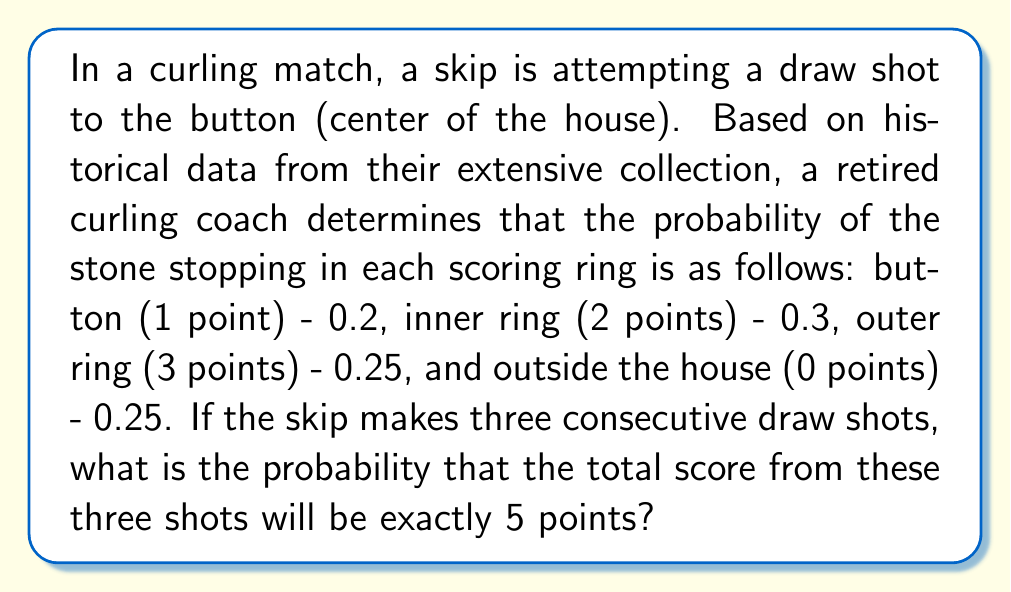Show me your answer to this math problem. Let's approach this step-by-step:

1) First, we need to identify all the possible combinations of shots that result in a total of 5 points. These are:
   - 1 + 1 + 3
   - 1 + 2 + 2
   - 2 + 3 + 0

2) Now, let's calculate the probability of each combination:

   a) P(1 + 1 + 3) = $0.2 \times 0.2 \times 0.25 \times 3! = 0.03$
      (The 3! accounts for all possible orders of these shots)

   b) P(1 + 2 + 2) = $0.2 \times 0.3 \times 0.3 \times 3 = 0.054$
      (The 3 accounts for the three possible positions of the 1-point shot)

   c) P(2 + 3 + 0) = $0.3 \times 0.25 \times 0.25 \times 3! = 0.05625$
      (The 3! accounts for all possible orders of these shots)

3) The total probability is the sum of these individual probabilities:

   P(total = 5) = $0.03 + 0.054 + 0.05625 = 0.14025$

Therefore, the probability of scoring exactly 5 points in three consecutive draw shots is 0.14025 or about 14.025%.
Answer: 0.14025 